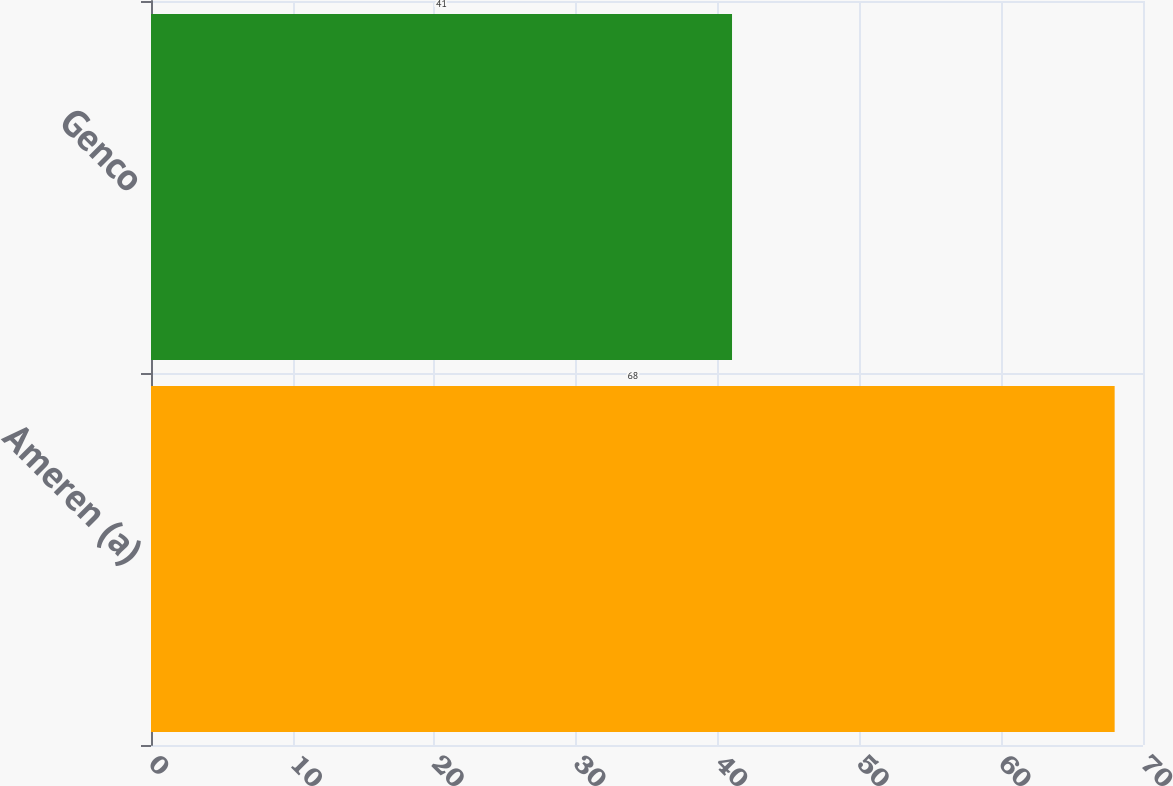<chart> <loc_0><loc_0><loc_500><loc_500><bar_chart><fcel>Ameren (a)<fcel>Genco<nl><fcel>68<fcel>41<nl></chart> 